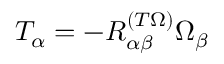<formula> <loc_0><loc_0><loc_500><loc_500>T _ { \alpha } = - { R } _ { \alpha \beta } ^ { ( T \Omega ) } \Omega _ { \beta }</formula> 